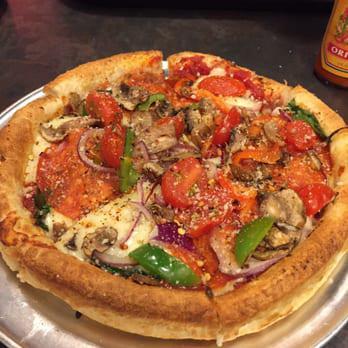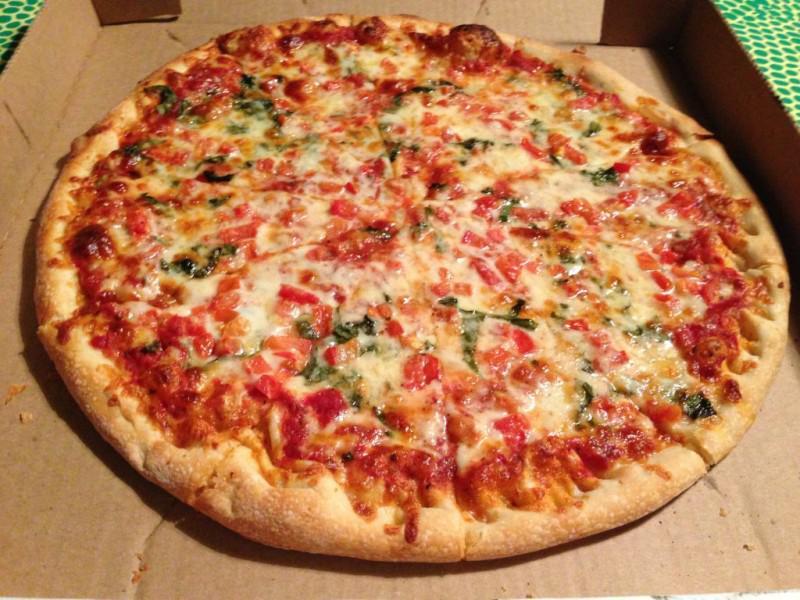The first image is the image on the left, the second image is the image on the right. Examine the images to the left and right. Is the description "Two pizzas have green toppings covering at least a small portion of the pizza." accurate? Answer yes or no. Yes. The first image is the image on the left, the second image is the image on the right. Analyze the images presented: Is the assertion "The left image features one sliced pizza on a round silver tray, with no slices missing and with similar toppings across the whole pizza." valid? Answer yes or no. Yes. 